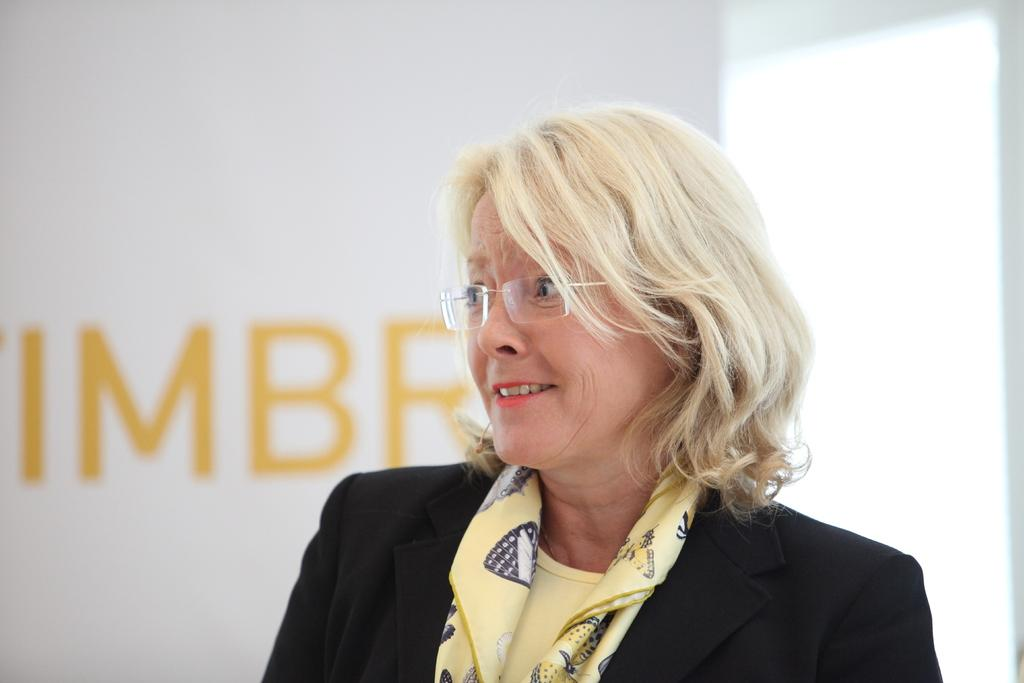Who is the main subject in the image? There is a lady in the image. What direction is the lady looking in? The lady is looking to the left side of the image. What is behind the lady in the image? There is a wall behind the lady. What can be seen on the wall? There is some text on the wall. How many dogs are sitting in the frame with the lady? There are no dogs present in the image, and the term "frame" is not applicable as it refers to a physical border around a photograph or painting, which is not mentioned in the facts. 